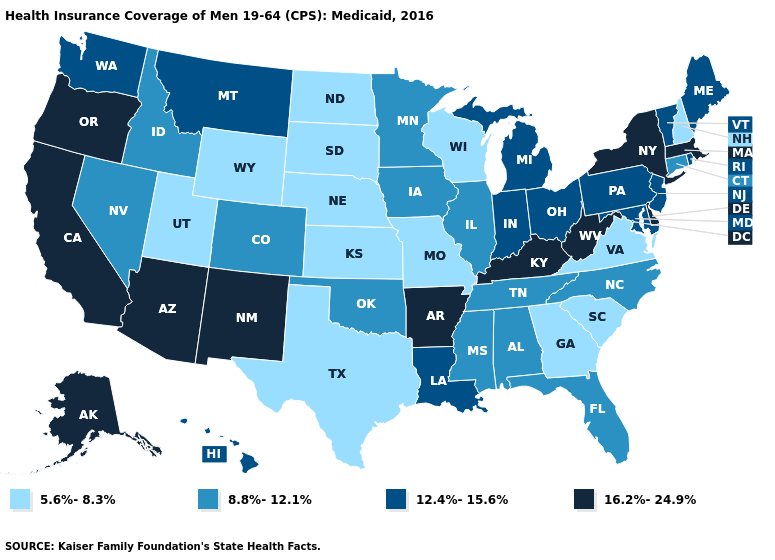Name the states that have a value in the range 5.6%-8.3%?
Quick response, please. Georgia, Kansas, Missouri, Nebraska, New Hampshire, North Dakota, South Carolina, South Dakota, Texas, Utah, Virginia, Wisconsin, Wyoming. What is the lowest value in the USA?
Write a very short answer. 5.6%-8.3%. Does Nevada have the lowest value in the USA?
Keep it brief. No. Name the states that have a value in the range 16.2%-24.9%?
Be succinct. Alaska, Arizona, Arkansas, California, Delaware, Kentucky, Massachusetts, New Mexico, New York, Oregon, West Virginia. Name the states that have a value in the range 8.8%-12.1%?
Keep it brief. Alabama, Colorado, Connecticut, Florida, Idaho, Illinois, Iowa, Minnesota, Mississippi, Nevada, North Carolina, Oklahoma, Tennessee. What is the value of Texas?
Keep it brief. 5.6%-8.3%. Among the states that border Colorado , which have the lowest value?
Be succinct. Kansas, Nebraska, Utah, Wyoming. Which states hav the highest value in the South?
Write a very short answer. Arkansas, Delaware, Kentucky, West Virginia. Among the states that border Vermont , does New Hampshire have the highest value?
Quick response, please. No. Name the states that have a value in the range 16.2%-24.9%?
Write a very short answer. Alaska, Arizona, Arkansas, California, Delaware, Kentucky, Massachusetts, New Mexico, New York, Oregon, West Virginia. Which states have the highest value in the USA?
Quick response, please. Alaska, Arizona, Arkansas, California, Delaware, Kentucky, Massachusetts, New Mexico, New York, Oregon, West Virginia. Does the first symbol in the legend represent the smallest category?
Be succinct. Yes. Name the states that have a value in the range 12.4%-15.6%?
Quick response, please. Hawaii, Indiana, Louisiana, Maine, Maryland, Michigan, Montana, New Jersey, Ohio, Pennsylvania, Rhode Island, Vermont, Washington. Among the states that border Rhode Island , which have the highest value?
Answer briefly. Massachusetts. Does Illinois have a higher value than Maryland?
Keep it brief. No. 